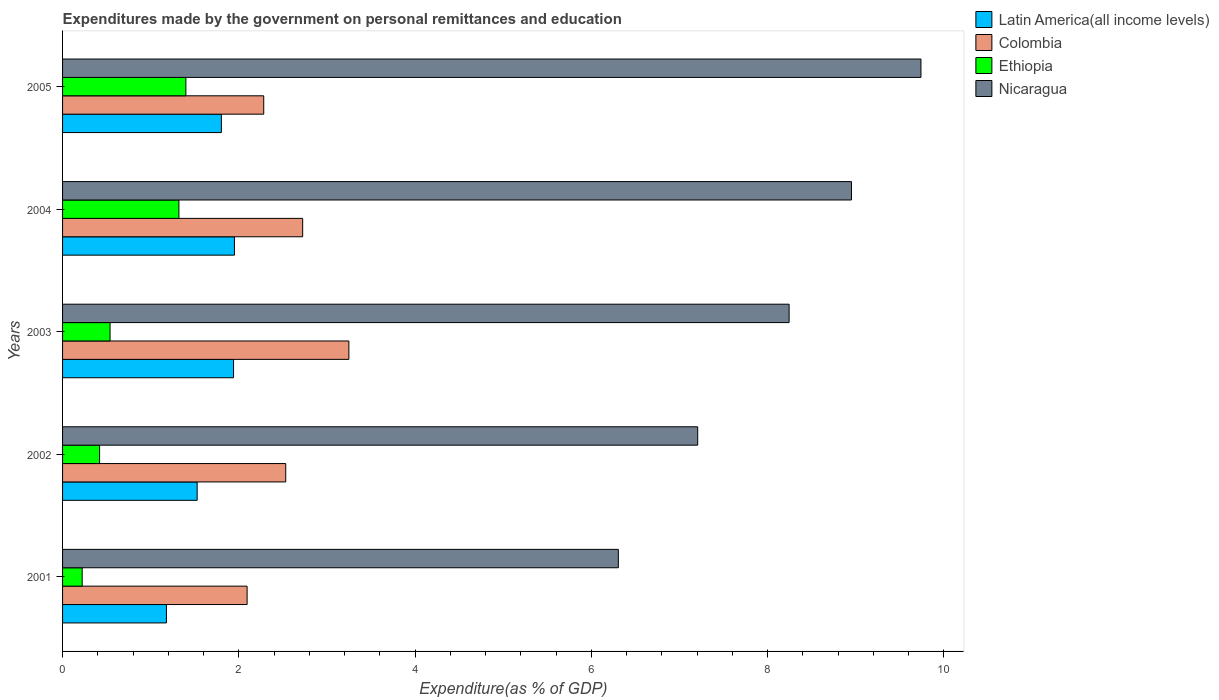How many different coloured bars are there?
Your response must be concise. 4. How many groups of bars are there?
Offer a very short reply. 5. Are the number of bars on each tick of the Y-axis equal?
Offer a terse response. Yes. How many bars are there on the 2nd tick from the top?
Offer a terse response. 4. How many bars are there on the 1st tick from the bottom?
Your response must be concise. 4. What is the label of the 5th group of bars from the top?
Provide a short and direct response. 2001. What is the expenditures made by the government on personal remittances and education in Nicaragua in 2002?
Keep it short and to the point. 7.21. Across all years, what is the maximum expenditures made by the government on personal remittances and education in Colombia?
Make the answer very short. 3.25. Across all years, what is the minimum expenditures made by the government on personal remittances and education in Colombia?
Keep it short and to the point. 2.09. In which year was the expenditures made by the government on personal remittances and education in Nicaragua maximum?
Provide a short and direct response. 2005. In which year was the expenditures made by the government on personal remittances and education in Colombia minimum?
Provide a succinct answer. 2001. What is the total expenditures made by the government on personal remittances and education in Nicaragua in the graph?
Offer a very short reply. 40.45. What is the difference between the expenditures made by the government on personal remittances and education in Colombia in 2002 and that in 2003?
Your answer should be compact. -0.72. What is the difference between the expenditures made by the government on personal remittances and education in Nicaragua in 2004 and the expenditures made by the government on personal remittances and education in Latin America(all income levels) in 2002?
Offer a very short reply. 7.42. What is the average expenditures made by the government on personal remittances and education in Nicaragua per year?
Keep it short and to the point. 8.09. In the year 2004, what is the difference between the expenditures made by the government on personal remittances and education in Nicaragua and expenditures made by the government on personal remittances and education in Colombia?
Offer a terse response. 6.23. What is the ratio of the expenditures made by the government on personal remittances and education in Ethiopia in 2002 to that in 2005?
Offer a very short reply. 0.3. Is the expenditures made by the government on personal remittances and education in Latin America(all income levels) in 2001 less than that in 2004?
Your response must be concise. Yes. Is the difference between the expenditures made by the government on personal remittances and education in Nicaragua in 2002 and 2005 greater than the difference between the expenditures made by the government on personal remittances and education in Colombia in 2002 and 2005?
Your response must be concise. No. What is the difference between the highest and the second highest expenditures made by the government on personal remittances and education in Ethiopia?
Ensure brevity in your answer.  0.08. What is the difference between the highest and the lowest expenditures made by the government on personal remittances and education in Latin America(all income levels)?
Your answer should be very brief. 0.77. What does the 4th bar from the top in 2003 represents?
Give a very brief answer. Latin America(all income levels). What does the 4th bar from the bottom in 2001 represents?
Give a very brief answer. Nicaragua. Is it the case that in every year, the sum of the expenditures made by the government on personal remittances and education in Latin America(all income levels) and expenditures made by the government on personal remittances and education in Nicaragua is greater than the expenditures made by the government on personal remittances and education in Colombia?
Offer a terse response. Yes. How many bars are there?
Provide a short and direct response. 20. Are all the bars in the graph horizontal?
Your response must be concise. Yes. How many years are there in the graph?
Your answer should be compact. 5. Are the values on the major ticks of X-axis written in scientific E-notation?
Offer a very short reply. No. Does the graph contain any zero values?
Offer a very short reply. No. Where does the legend appear in the graph?
Offer a terse response. Top right. How are the legend labels stacked?
Your response must be concise. Vertical. What is the title of the graph?
Provide a short and direct response. Expenditures made by the government on personal remittances and education. Does "Germany" appear as one of the legend labels in the graph?
Keep it short and to the point. No. What is the label or title of the X-axis?
Keep it short and to the point. Expenditure(as % of GDP). What is the label or title of the Y-axis?
Offer a very short reply. Years. What is the Expenditure(as % of GDP) in Latin America(all income levels) in 2001?
Offer a very short reply. 1.18. What is the Expenditure(as % of GDP) in Colombia in 2001?
Provide a short and direct response. 2.09. What is the Expenditure(as % of GDP) in Ethiopia in 2001?
Give a very brief answer. 0.22. What is the Expenditure(as % of GDP) in Nicaragua in 2001?
Provide a short and direct response. 6.31. What is the Expenditure(as % of GDP) of Latin America(all income levels) in 2002?
Provide a succinct answer. 1.53. What is the Expenditure(as % of GDP) in Colombia in 2002?
Your answer should be very brief. 2.53. What is the Expenditure(as % of GDP) in Ethiopia in 2002?
Ensure brevity in your answer.  0.42. What is the Expenditure(as % of GDP) in Nicaragua in 2002?
Your answer should be very brief. 7.21. What is the Expenditure(as % of GDP) of Latin America(all income levels) in 2003?
Keep it short and to the point. 1.94. What is the Expenditure(as % of GDP) of Colombia in 2003?
Provide a succinct answer. 3.25. What is the Expenditure(as % of GDP) of Ethiopia in 2003?
Provide a succinct answer. 0.54. What is the Expenditure(as % of GDP) in Nicaragua in 2003?
Offer a terse response. 8.24. What is the Expenditure(as % of GDP) of Latin America(all income levels) in 2004?
Your response must be concise. 1.95. What is the Expenditure(as % of GDP) of Colombia in 2004?
Offer a terse response. 2.72. What is the Expenditure(as % of GDP) of Ethiopia in 2004?
Ensure brevity in your answer.  1.32. What is the Expenditure(as % of GDP) in Nicaragua in 2004?
Provide a succinct answer. 8.95. What is the Expenditure(as % of GDP) in Latin America(all income levels) in 2005?
Provide a short and direct response. 1.8. What is the Expenditure(as % of GDP) in Colombia in 2005?
Your response must be concise. 2.28. What is the Expenditure(as % of GDP) in Ethiopia in 2005?
Ensure brevity in your answer.  1.4. What is the Expenditure(as % of GDP) of Nicaragua in 2005?
Your response must be concise. 9.74. Across all years, what is the maximum Expenditure(as % of GDP) in Latin America(all income levels)?
Ensure brevity in your answer.  1.95. Across all years, what is the maximum Expenditure(as % of GDP) in Colombia?
Offer a terse response. 3.25. Across all years, what is the maximum Expenditure(as % of GDP) in Ethiopia?
Make the answer very short. 1.4. Across all years, what is the maximum Expenditure(as % of GDP) in Nicaragua?
Your answer should be compact. 9.74. Across all years, what is the minimum Expenditure(as % of GDP) in Latin America(all income levels)?
Offer a very short reply. 1.18. Across all years, what is the minimum Expenditure(as % of GDP) in Colombia?
Give a very brief answer. 2.09. Across all years, what is the minimum Expenditure(as % of GDP) of Ethiopia?
Your answer should be very brief. 0.22. Across all years, what is the minimum Expenditure(as % of GDP) of Nicaragua?
Your response must be concise. 6.31. What is the total Expenditure(as % of GDP) in Latin America(all income levels) in the graph?
Your response must be concise. 8.4. What is the total Expenditure(as % of GDP) in Colombia in the graph?
Keep it short and to the point. 12.88. What is the total Expenditure(as % of GDP) of Ethiopia in the graph?
Your response must be concise. 3.9. What is the total Expenditure(as % of GDP) of Nicaragua in the graph?
Provide a succinct answer. 40.45. What is the difference between the Expenditure(as % of GDP) in Latin America(all income levels) in 2001 and that in 2002?
Your answer should be very brief. -0.35. What is the difference between the Expenditure(as % of GDP) in Colombia in 2001 and that in 2002?
Keep it short and to the point. -0.44. What is the difference between the Expenditure(as % of GDP) in Ethiopia in 2001 and that in 2002?
Provide a succinct answer. -0.2. What is the difference between the Expenditure(as % of GDP) in Nicaragua in 2001 and that in 2002?
Provide a short and direct response. -0.9. What is the difference between the Expenditure(as % of GDP) of Latin America(all income levels) in 2001 and that in 2003?
Give a very brief answer. -0.76. What is the difference between the Expenditure(as % of GDP) of Colombia in 2001 and that in 2003?
Your response must be concise. -1.15. What is the difference between the Expenditure(as % of GDP) in Ethiopia in 2001 and that in 2003?
Offer a terse response. -0.32. What is the difference between the Expenditure(as % of GDP) in Nicaragua in 2001 and that in 2003?
Your response must be concise. -1.94. What is the difference between the Expenditure(as % of GDP) of Latin America(all income levels) in 2001 and that in 2004?
Provide a succinct answer. -0.77. What is the difference between the Expenditure(as % of GDP) in Colombia in 2001 and that in 2004?
Provide a succinct answer. -0.63. What is the difference between the Expenditure(as % of GDP) in Ethiopia in 2001 and that in 2004?
Give a very brief answer. -1.1. What is the difference between the Expenditure(as % of GDP) in Nicaragua in 2001 and that in 2004?
Provide a short and direct response. -2.65. What is the difference between the Expenditure(as % of GDP) of Latin America(all income levels) in 2001 and that in 2005?
Your response must be concise. -0.62. What is the difference between the Expenditure(as % of GDP) of Colombia in 2001 and that in 2005?
Make the answer very short. -0.19. What is the difference between the Expenditure(as % of GDP) in Ethiopia in 2001 and that in 2005?
Keep it short and to the point. -1.18. What is the difference between the Expenditure(as % of GDP) of Nicaragua in 2001 and that in 2005?
Offer a very short reply. -3.43. What is the difference between the Expenditure(as % of GDP) of Latin America(all income levels) in 2002 and that in 2003?
Offer a terse response. -0.41. What is the difference between the Expenditure(as % of GDP) in Colombia in 2002 and that in 2003?
Give a very brief answer. -0.72. What is the difference between the Expenditure(as % of GDP) in Ethiopia in 2002 and that in 2003?
Your response must be concise. -0.12. What is the difference between the Expenditure(as % of GDP) of Nicaragua in 2002 and that in 2003?
Make the answer very short. -1.04. What is the difference between the Expenditure(as % of GDP) of Latin America(all income levels) in 2002 and that in 2004?
Provide a succinct answer. -0.42. What is the difference between the Expenditure(as % of GDP) in Colombia in 2002 and that in 2004?
Give a very brief answer. -0.19. What is the difference between the Expenditure(as % of GDP) of Ethiopia in 2002 and that in 2004?
Make the answer very short. -0.9. What is the difference between the Expenditure(as % of GDP) of Nicaragua in 2002 and that in 2004?
Ensure brevity in your answer.  -1.74. What is the difference between the Expenditure(as % of GDP) in Latin America(all income levels) in 2002 and that in 2005?
Offer a terse response. -0.28. What is the difference between the Expenditure(as % of GDP) of Colombia in 2002 and that in 2005?
Provide a short and direct response. 0.25. What is the difference between the Expenditure(as % of GDP) of Ethiopia in 2002 and that in 2005?
Provide a succinct answer. -0.98. What is the difference between the Expenditure(as % of GDP) of Nicaragua in 2002 and that in 2005?
Provide a short and direct response. -2.53. What is the difference between the Expenditure(as % of GDP) in Latin America(all income levels) in 2003 and that in 2004?
Your answer should be very brief. -0.01. What is the difference between the Expenditure(as % of GDP) in Colombia in 2003 and that in 2004?
Provide a succinct answer. 0.52. What is the difference between the Expenditure(as % of GDP) of Ethiopia in 2003 and that in 2004?
Ensure brevity in your answer.  -0.78. What is the difference between the Expenditure(as % of GDP) of Nicaragua in 2003 and that in 2004?
Your answer should be very brief. -0.71. What is the difference between the Expenditure(as % of GDP) in Latin America(all income levels) in 2003 and that in 2005?
Your answer should be compact. 0.14. What is the difference between the Expenditure(as % of GDP) of Ethiopia in 2003 and that in 2005?
Give a very brief answer. -0.86. What is the difference between the Expenditure(as % of GDP) of Nicaragua in 2003 and that in 2005?
Keep it short and to the point. -1.5. What is the difference between the Expenditure(as % of GDP) in Latin America(all income levels) in 2004 and that in 2005?
Give a very brief answer. 0.15. What is the difference between the Expenditure(as % of GDP) in Colombia in 2004 and that in 2005?
Make the answer very short. 0.44. What is the difference between the Expenditure(as % of GDP) in Ethiopia in 2004 and that in 2005?
Make the answer very short. -0.08. What is the difference between the Expenditure(as % of GDP) of Nicaragua in 2004 and that in 2005?
Your response must be concise. -0.79. What is the difference between the Expenditure(as % of GDP) of Latin America(all income levels) in 2001 and the Expenditure(as % of GDP) of Colombia in 2002?
Make the answer very short. -1.35. What is the difference between the Expenditure(as % of GDP) in Latin America(all income levels) in 2001 and the Expenditure(as % of GDP) in Ethiopia in 2002?
Offer a very short reply. 0.76. What is the difference between the Expenditure(as % of GDP) in Latin America(all income levels) in 2001 and the Expenditure(as % of GDP) in Nicaragua in 2002?
Offer a terse response. -6.03. What is the difference between the Expenditure(as % of GDP) in Colombia in 2001 and the Expenditure(as % of GDP) in Ethiopia in 2002?
Your response must be concise. 1.67. What is the difference between the Expenditure(as % of GDP) in Colombia in 2001 and the Expenditure(as % of GDP) in Nicaragua in 2002?
Give a very brief answer. -5.11. What is the difference between the Expenditure(as % of GDP) of Ethiopia in 2001 and the Expenditure(as % of GDP) of Nicaragua in 2002?
Provide a short and direct response. -6.98. What is the difference between the Expenditure(as % of GDP) of Latin America(all income levels) in 2001 and the Expenditure(as % of GDP) of Colombia in 2003?
Give a very brief answer. -2.07. What is the difference between the Expenditure(as % of GDP) in Latin America(all income levels) in 2001 and the Expenditure(as % of GDP) in Ethiopia in 2003?
Your answer should be compact. 0.64. What is the difference between the Expenditure(as % of GDP) in Latin America(all income levels) in 2001 and the Expenditure(as % of GDP) in Nicaragua in 2003?
Keep it short and to the point. -7.07. What is the difference between the Expenditure(as % of GDP) of Colombia in 2001 and the Expenditure(as % of GDP) of Ethiopia in 2003?
Give a very brief answer. 1.56. What is the difference between the Expenditure(as % of GDP) of Colombia in 2001 and the Expenditure(as % of GDP) of Nicaragua in 2003?
Your answer should be compact. -6.15. What is the difference between the Expenditure(as % of GDP) of Ethiopia in 2001 and the Expenditure(as % of GDP) of Nicaragua in 2003?
Your response must be concise. -8.02. What is the difference between the Expenditure(as % of GDP) of Latin America(all income levels) in 2001 and the Expenditure(as % of GDP) of Colombia in 2004?
Make the answer very short. -1.55. What is the difference between the Expenditure(as % of GDP) of Latin America(all income levels) in 2001 and the Expenditure(as % of GDP) of Ethiopia in 2004?
Provide a short and direct response. -0.14. What is the difference between the Expenditure(as % of GDP) in Latin America(all income levels) in 2001 and the Expenditure(as % of GDP) in Nicaragua in 2004?
Offer a very short reply. -7.77. What is the difference between the Expenditure(as % of GDP) in Colombia in 2001 and the Expenditure(as % of GDP) in Ethiopia in 2004?
Your answer should be very brief. 0.77. What is the difference between the Expenditure(as % of GDP) of Colombia in 2001 and the Expenditure(as % of GDP) of Nicaragua in 2004?
Your answer should be very brief. -6.86. What is the difference between the Expenditure(as % of GDP) of Ethiopia in 2001 and the Expenditure(as % of GDP) of Nicaragua in 2004?
Provide a short and direct response. -8.73. What is the difference between the Expenditure(as % of GDP) in Latin America(all income levels) in 2001 and the Expenditure(as % of GDP) in Colombia in 2005?
Give a very brief answer. -1.1. What is the difference between the Expenditure(as % of GDP) of Latin America(all income levels) in 2001 and the Expenditure(as % of GDP) of Ethiopia in 2005?
Your response must be concise. -0.22. What is the difference between the Expenditure(as % of GDP) in Latin America(all income levels) in 2001 and the Expenditure(as % of GDP) in Nicaragua in 2005?
Your response must be concise. -8.56. What is the difference between the Expenditure(as % of GDP) in Colombia in 2001 and the Expenditure(as % of GDP) in Ethiopia in 2005?
Provide a short and direct response. 0.69. What is the difference between the Expenditure(as % of GDP) in Colombia in 2001 and the Expenditure(as % of GDP) in Nicaragua in 2005?
Ensure brevity in your answer.  -7.65. What is the difference between the Expenditure(as % of GDP) of Ethiopia in 2001 and the Expenditure(as % of GDP) of Nicaragua in 2005?
Keep it short and to the point. -9.52. What is the difference between the Expenditure(as % of GDP) in Latin America(all income levels) in 2002 and the Expenditure(as % of GDP) in Colombia in 2003?
Your answer should be very brief. -1.72. What is the difference between the Expenditure(as % of GDP) of Latin America(all income levels) in 2002 and the Expenditure(as % of GDP) of Ethiopia in 2003?
Offer a terse response. 0.99. What is the difference between the Expenditure(as % of GDP) in Latin America(all income levels) in 2002 and the Expenditure(as % of GDP) in Nicaragua in 2003?
Your response must be concise. -6.72. What is the difference between the Expenditure(as % of GDP) of Colombia in 2002 and the Expenditure(as % of GDP) of Ethiopia in 2003?
Offer a very short reply. 1.99. What is the difference between the Expenditure(as % of GDP) in Colombia in 2002 and the Expenditure(as % of GDP) in Nicaragua in 2003?
Provide a short and direct response. -5.71. What is the difference between the Expenditure(as % of GDP) in Ethiopia in 2002 and the Expenditure(as % of GDP) in Nicaragua in 2003?
Provide a short and direct response. -7.82. What is the difference between the Expenditure(as % of GDP) of Latin America(all income levels) in 2002 and the Expenditure(as % of GDP) of Colombia in 2004?
Your answer should be compact. -1.2. What is the difference between the Expenditure(as % of GDP) in Latin America(all income levels) in 2002 and the Expenditure(as % of GDP) in Ethiopia in 2004?
Ensure brevity in your answer.  0.21. What is the difference between the Expenditure(as % of GDP) of Latin America(all income levels) in 2002 and the Expenditure(as % of GDP) of Nicaragua in 2004?
Provide a short and direct response. -7.42. What is the difference between the Expenditure(as % of GDP) of Colombia in 2002 and the Expenditure(as % of GDP) of Ethiopia in 2004?
Your response must be concise. 1.21. What is the difference between the Expenditure(as % of GDP) in Colombia in 2002 and the Expenditure(as % of GDP) in Nicaragua in 2004?
Offer a very short reply. -6.42. What is the difference between the Expenditure(as % of GDP) in Ethiopia in 2002 and the Expenditure(as % of GDP) in Nicaragua in 2004?
Provide a short and direct response. -8.53. What is the difference between the Expenditure(as % of GDP) in Latin America(all income levels) in 2002 and the Expenditure(as % of GDP) in Colombia in 2005?
Your answer should be very brief. -0.76. What is the difference between the Expenditure(as % of GDP) in Latin America(all income levels) in 2002 and the Expenditure(as % of GDP) in Ethiopia in 2005?
Keep it short and to the point. 0.13. What is the difference between the Expenditure(as % of GDP) of Latin America(all income levels) in 2002 and the Expenditure(as % of GDP) of Nicaragua in 2005?
Offer a very short reply. -8.21. What is the difference between the Expenditure(as % of GDP) of Colombia in 2002 and the Expenditure(as % of GDP) of Ethiopia in 2005?
Offer a terse response. 1.13. What is the difference between the Expenditure(as % of GDP) of Colombia in 2002 and the Expenditure(as % of GDP) of Nicaragua in 2005?
Give a very brief answer. -7.21. What is the difference between the Expenditure(as % of GDP) in Ethiopia in 2002 and the Expenditure(as % of GDP) in Nicaragua in 2005?
Offer a terse response. -9.32. What is the difference between the Expenditure(as % of GDP) of Latin America(all income levels) in 2003 and the Expenditure(as % of GDP) of Colombia in 2004?
Your answer should be very brief. -0.78. What is the difference between the Expenditure(as % of GDP) of Latin America(all income levels) in 2003 and the Expenditure(as % of GDP) of Ethiopia in 2004?
Your answer should be compact. 0.62. What is the difference between the Expenditure(as % of GDP) of Latin America(all income levels) in 2003 and the Expenditure(as % of GDP) of Nicaragua in 2004?
Provide a short and direct response. -7.01. What is the difference between the Expenditure(as % of GDP) in Colombia in 2003 and the Expenditure(as % of GDP) in Ethiopia in 2004?
Provide a short and direct response. 1.93. What is the difference between the Expenditure(as % of GDP) of Colombia in 2003 and the Expenditure(as % of GDP) of Nicaragua in 2004?
Provide a short and direct response. -5.7. What is the difference between the Expenditure(as % of GDP) of Ethiopia in 2003 and the Expenditure(as % of GDP) of Nicaragua in 2004?
Give a very brief answer. -8.41. What is the difference between the Expenditure(as % of GDP) of Latin America(all income levels) in 2003 and the Expenditure(as % of GDP) of Colombia in 2005?
Ensure brevity in your answer.  -0.34. What is the difference between the Expenditure(as % of GDP) in Latin America(all income levels) in 2003 and the Expenditure(as % of GDP) in Ethiopia in 2005?
Provide a succinct answer. 0.54. What is the difference between the Expenditure(as % of GDP) in Latin America(all income levels) in 2003 and the Expenditure(as % of GDP) in Nicaragua in 2005?
Your answer should be very brief. -7.8. What is the difference between the Expenditure(as % of GDP) of Colombia in 2003 and the Expenditure(as % of GDP) of Ethiopia in 2005?
Your answer should be very brief. 1.85. What is the difference between the Expenditure(as % of GDP) of Colombia in 2003 and the Expenditure(as % of GDP) of Nicaragua in 2005?
Your answer should be very brief. -6.49. What is the difference between the Expenditure(as % of GDP) of Ethiopia in 2003 and the Expenditure(as % of GDP) of Nicaragua in 2005?
Provide a short and direct response. -9.2. What is the difference between the Expenditure(as % of GDP) in Latin America(all income levels) in 2004 and the Expenditure(as % of GDP) in Colombia in 2005?
Offer a terse response. -0.33. What is the difference between the Expenditure(as % of GDP) in Latin America(all income levels) in 2004 and the Expenditure(as % of GDP) in Ethiopia in 2005?
Ensure brevity in your answer.  0.55. What is the difference between the Expenditure(as % of GDP) of Latin America(all income levels) in 2004 and the Expenditure(as % of GDP) of Nicaragua in 2005?
Provide a succinct answer. -7.79. What is the difference between the Expenditure(as % of GDP) of Colombia in 2004 and the Expenditure(as % of GDP) of Ethiopia in 2005?
Your answer should be compact. 1.33. What is the difference between the Expenditure(as % of GDP) in Colombia in 2004 and the Expenditure(as % of GDP) in Nicaragua in 2005?
Your response must be concise. -7.02. What is the difference between the Expenditure(as % of GDP) of Ethiopia in 2004 and the Expenditure(as % of GDP) of Nicaragua in 2005?
Provide a short and direct response. -8.42. What is the average Expenditure(as % of GDP) in Latin America(all income levels) per year?
Make the answer very short. 1.68. What is the average Expenditure(as % of GDP) of Colombia per year?
Ensure brevity in your answer.  2.58. What is the average Expenditure(as % of GDP) of Ethiopia per year?
Keep it short and to the point. 0.78. What is the average Expenditure(as % of GDP) in Nicaragua per year?
Provide a succinct answer. 8.09. In the year 2001, what is the difference between the Expenditure(as % of GDP) in Latin America(all income levels) and Expenditure(as % of GDP) in Colombia?
Your response must be concise. -0.92. In the year 2001, what is the difference between the Expenditure(as % of GDP) in Latin America(all income levels) and Expenditure(as % of GDP) in Ethiopia?
Keep it short and to the point. 0.96. In the year 2001, what is the difference between the Expenditure(as % of GDP) of Latin America(all income levels) and Expenditure(as % of GDP) of Nicaragua?
Keep it short and to the point. -5.13. In the year 2001, what is the difference between the Expenditure(as % of GDP) in Colombia and Expenditure(as % of GDP) in Ethiopia?
Offer a terse response. 1.87. In the year 2001, what is the difference between the Expenditure(as % of GDP) of Colombia and Expenditure(as % of GDP) of Nicaragua?
Offer a very short reply. -4.21. In the year 2001, what is the difference between the Expenditure(as % of GDP) of Ethiopia and Expenditure(as % of GDP) of Nicaragua?
Ensure brevity in your answer.  -6.08. In the year 2002, what is the difference between the Expenditure(as % of GDP) of Latin America(all income levels) and Expenditure(as % of GDP) of Colombia?
Offer a very short reply. -1.01. In the year 2002, what is the difference between the Expenditure(as % of GDP) of Latin America(all income levels) and Expenditure(as % of GDP) of Ethiopia?
Your answer should be compact. 1.11. In the year 2002, what is the difference between the Expenditure(as % of GDP) in Latin America(all income levels) and Expenditure(as % of GDP) in Nicaragua?
Your answer should be compact. -5.68. In the year 2002, what is the difference between the Expenditure(as % of GDP) in Colombia and Expenditure(as % of GDP) in Ethiopia?
Provide a succinct answer. 2.11. In the year 2002, what is the difference between the Expenditure(as % of GDP) of Colombia and Expenditure(as % of GDP) of Nicaragua?
Your response must be concise. -4.67. In the year 2002, what is the difference between the Expenditure(as % of GDP) of Ethiopia and Expenditure(as % of GDP) of Nicaragua?
Provide a short and direct response. -6.79. In the year 2003, what is the difference between the Expenditure(as % of GDP) of Latin America(all income levels) and Expenditure(as % of GDP) of Colombia?
Give a very brief answer. -1.31. In the year 2003, what is the difference between the Expenditure(as % of GDP) in Latin America(all income levels) and Expenditure(as % of GDP) in Ethiopia?
Make the answer very short. 1.4. In the year 2003, what is the difference between the Expenditure(as % of GDP) of Latin America(all income levels) and Expenditure(as % of GDP) of Nicaragua?
Give a very brief answer. -6.3. In the year 2003, what is the difference between the Expenditure(as % of GDP) in Colombia and Expenditure(as % of GDP) in Ethiopia?
Offer a terse response. 2.71. In the year 2003, what is the difference between the Expenditure(as % of GDP) in Colombia and Expenditure(as % of GDP) in Nicaragua?
Offer a very short reply. -5. In the year 2003, what is the difference between the Expenditure(as % of GDP) in Ethiopia and Expenditure(as % of GDP) in Nicaragua?
Your response must be concise. -7.71. In the year 2004, what is the difference between the Expenditure(as % of GDP) in Latin America(all income levels) and Expenditure(as % of GDP) in Colombia?
Your answer should be very brief. -0.77. In the year 2004, what is the difference between the Expenditure(as % of GDP) in Latin America(all income levels) and Expenditure(as % of GDP) in Ethiopia?
Keep it short and to the point. 0.63. In the year 2004, what is the difference between the Expenditure(as % of GDP) of Latin America(all income levels) and Expenditure(as % of GDP) of Nicaragua?
Ensure brevity in your answer.  -7. In the year 2004, what is the difference between the Expenditure(as % of GDP) in Colombia and Expenditure(as % of GDP) in Ethiopia?
Your answer should be very brief. 1.4. In the year 2004, what is the difference between the Expenditure(as % of GDP) in Colombia and Expenditure(as % of GDP) in Nicaragua?
Your response must be concise. -6.23. In the year 2004, what is the difference between the Expenditure(as % of GDP) of Ethiopia and Expenditure(as % of GDP) of Nicaragua?
Ensure brevity in your answer.  -7.63. In the year 2005, what is the difference between the Expenditure(as % of GDP) in Latin America(all income levels) and Expenditure(as % of GDP) in Colombia?
Ensure brevity in your answer.  -0.48. In the year 2005, what is the difference between the Expenditure(as % of GDP) of Latin America(all income levels) and Expenditure(as % of GDP) of Ethiopia?
Your response must be concise. 0.4. In the year 2005, what is the difference between the Expenditure(as % of GDP) in Latin America(all income levels) and Expenditure(as % of GDP) in Nicaragua?
Provide a short and direct response. -7.94. In the year 2005, what is the difference between the Expenditure(as % of GDP) of Colombia and Expenditure(as % of GDP) of Ethiopia?
Keep it short and to the point. 0.88. In the year 2005, what is the difference between the Expenditure(as % of GDP) in Colombia and Expenditure(as % of GDP) in Nicaragua?
Provide a succinct answer. -7.46. In the year 2005, what is the difference between the Expenditure(as % of GDP) of Ethiopia and Expenditure(as % of GDP) of Nicaragua?
Give a very brief answer. -8.34. What is the ratio of the Expenditure(as % of GDP) in Latin America(all income levels) in 2001 to that in 2002?
Ensure brevity in your answer.  0.77. What is the ratio of the Expenditure(as % of GDP) in Colombia in 2001 to that in 2002?
Your answer should be compact. 0.83. What is the ratio of the Expenditure(as % of GDP) of Ethiopia in 2001 to that in 2002?
Your answer should be very brief. 0.53. What is the ratio of the Expenditure(as % of GDP) of Nicaragua in 2001 to that in 2002?
Make the answer very short. 0.88. What is the ratio of the Expenditure(as % of GDP) of Latin America(all income levels) in 2001 to that in 2003?
Offer a very short reply. 0.61. What is the ratio of the Expenditure(as % of GDP) in Colombia in 2001 to that in 2003?
Offer a terse response. 0.64. What is the ratio of the Expenditure(as % of GDP) in Ethiopia in 2001 to that in 2003?
Provide a short and direct response. 0.41. What is the ratio of the Expenditure(as % of GDP) of Nicaragua in 2001 to that in 2003?
Give a very brief answer. 0.76. What is the ratio of the Expenditure(as % of GDP) in Latin America(all income levels) in 2001 to that in 2004?
Provide a succinct answer. 0.6. What is the ratio of the Expenditure(as % of GDP) of Colombia in 2001 to that in 2004?
Your answer should be compact. 0.77. What is the ratio of the Expenditure(as % of GDP) in Ethiopia in 2001 to that in 2004?
Your response must be concise. 0.17. What is the ratio of the Expenditure(as % of GDP) of Nicaragua in 2001 to that in 2004?
Your answer should be very brief. 0.7. What is the ratio of the Expenditure(as % of GDP) of Latin America(all income levels) in 2001 to that in 2005?
Make the answer very short. 0.65. What is the ratio of the Expenditure(as % of GDP) in Colombia in 2001 to that in 2005?
Keep it short and to the point. 0.92. What is the ratio of the Expenditure(as % of GDP) of Ethiopia in 2001 to that in 2005?
Keep it short and to the point. 0.16. What is the ratio of the Expenditure(as % of GDP) in Nicaragua in 2001 to that in 2005?
Keep it short and to the point. 0.65. What is the ratio of the Expenditure(as % of GDP) in Latin America(all income levels) in 2002 to that in 2003?
Offer a terse response. 0.79. What is the ratio of the Expenditure(as % of GDP) in Colombia in 2002 to that in 2003?
Provide a short and direct response. 0.78. What is the ratio of the Expenditure(as % of GDP) of Ethiopia in 2002 to that in 2003?
Your answer should be very brief. 0.78. What is the ratio of the Expenditure(as % of GDP) of Nicaragua in 2002 to that in 2003?
Offer a terse response. 0.87. What is the ratio of the Expenditure(as % of GDP) in Latin America(all income levels) in 2002 to that in 2004?
Provide a succinct answer. 0.78. What is the ratio of the Expenditure(as % of GDP) of Colombia in 2002 to that in 2004?
Your response must be concise. 0.93. What is the ratio of the Expenditure(as % of GDP) of Ethiopia in 2002 to that in 2004?
Ensure brevity in your answer.  0.32. What is the ratio of the Expenditure(as % of GDP) of Nicaragua in 2002 to that in 2004?
Provide a short and direct response. 0.81. What is the ratio of the Expenditure(as % of GDP) in Latin America(all income levels) in 2002 to that in 2005?
Your response must be concise. 0.85. What is the ratio of the Expenditure(as % of GDP) in Colombia in 2002 to that in 2005?
Your answer should be very brief. 1.11. What is the ratio of the Expenditure(as % of GDP) in Ethiopia in 2002 to that in 2005?
Ensure brevity in your answer.  0.3. What is the ratio of the Expenditure(as % of GDP) in Nicaragua in 2002 to that in 2005?
Offer a very short reply. 0.74. What is the ratio of the Expenditure(as % of GDP) in Colombia in 2003 to that in 2004?
Make the answer very short. 1.19. What is the ratio of the Expenditure(as % of GDP) of Ethiopia in 2003 to that in 2004?
Your response must be concise. 0.41. What is the ratio of the Expenditure(as % of GDP) in Nicaragua in 2003 to that in 2004?
Your response must be concise. 0.92. What is the ratio of the Expenditure(as % of GDP) of Latin America(all income levels) in 2003 to that in 2005?
Provide a succinct answer. 1.08. What is the ratio of the Expenditure(as % of GDP) in Colombia in 2003 to that in 2005?
Make the answer very short. 1.42. What is the ratio of the Expenditure(as % of GDP) in Ethiopia in 2003 to that in 2005?
Offer a terse response. 0.39. What is the ratio of the Expenditure(as % of GDP) of Nicaragua in 2003 to that in 2005?
Give a very brief answer. 0.85. What is the ratio of the Expenditure(as % of GDP) of Latin America(all income levels) in 2004 to that in 2005?
Offer a terse response. 1.08. What is the ratio of the Expenditure(as % of GDP) in Colombia in 2004 to that in 2005?
Offer a very short reply. 1.19. What is the ratio of the Expenditure(as % of GDP) of Ethiopia in 2004 to that in 2005?
Your answer should be compact. 0.94. What is the ratio of the Expenditure(as % of GDP) in Nicaragua in 2004 to that in 2005?
Your response must be concise. 0.92. What is the difference between the highest and the second highest Expenditure(as % of GDP) in Latin America(all income levels)?
Your answer should be compact. 0.01. What is the difference between the highest and the second highest Expenditure(as % of GDP) of Colombia?
Offer a very short reply. 0.52. What is the difference between the highest and the second highest Expenditure(as % of GDP) in Ethiopia?
Give a very brief answer. 0.08. What is the difference between the highest and the second highest Expenditure(as % of GDP) in Nicaragua?
Your response must be concise. 0.79. What is the difference between the highest and the lowest Expenditure(as % of GDP) in Latin America(all income levels)?
Provide a short and direct response. 0.77. What is the difference between the highest and the lowest Expenditure(as % of GDP) of Colombia?
Your response must be concise. 1.15. What is the difference between the highest and the lowest Expenditure(as % of GDP) of Ethiopia?
Give a very brief answer. 1.18. What is the difference between the highest and the lowest Expenditure(as % of GDP) in Nicaragua?
Give a very brief answer. 3.43. 